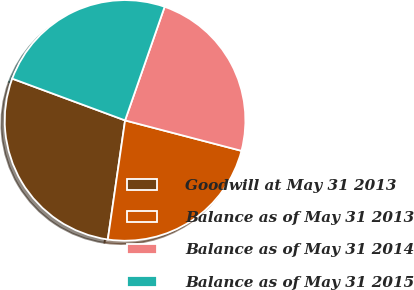Convert chart to OTSL. <chart><loc_0><loc_0><loc_500><loc_500><pie_chart><fcel>Goodwill at May 31 2013<fcel>Balance as of May 31 2013<fcel>Balance as of May 31 2014<fcel>Balance as of May 31 2015<nl><fcel>28.35%<fcel>23.22%<fcel>23.74%<fcel>24.69%<nl></chart> 